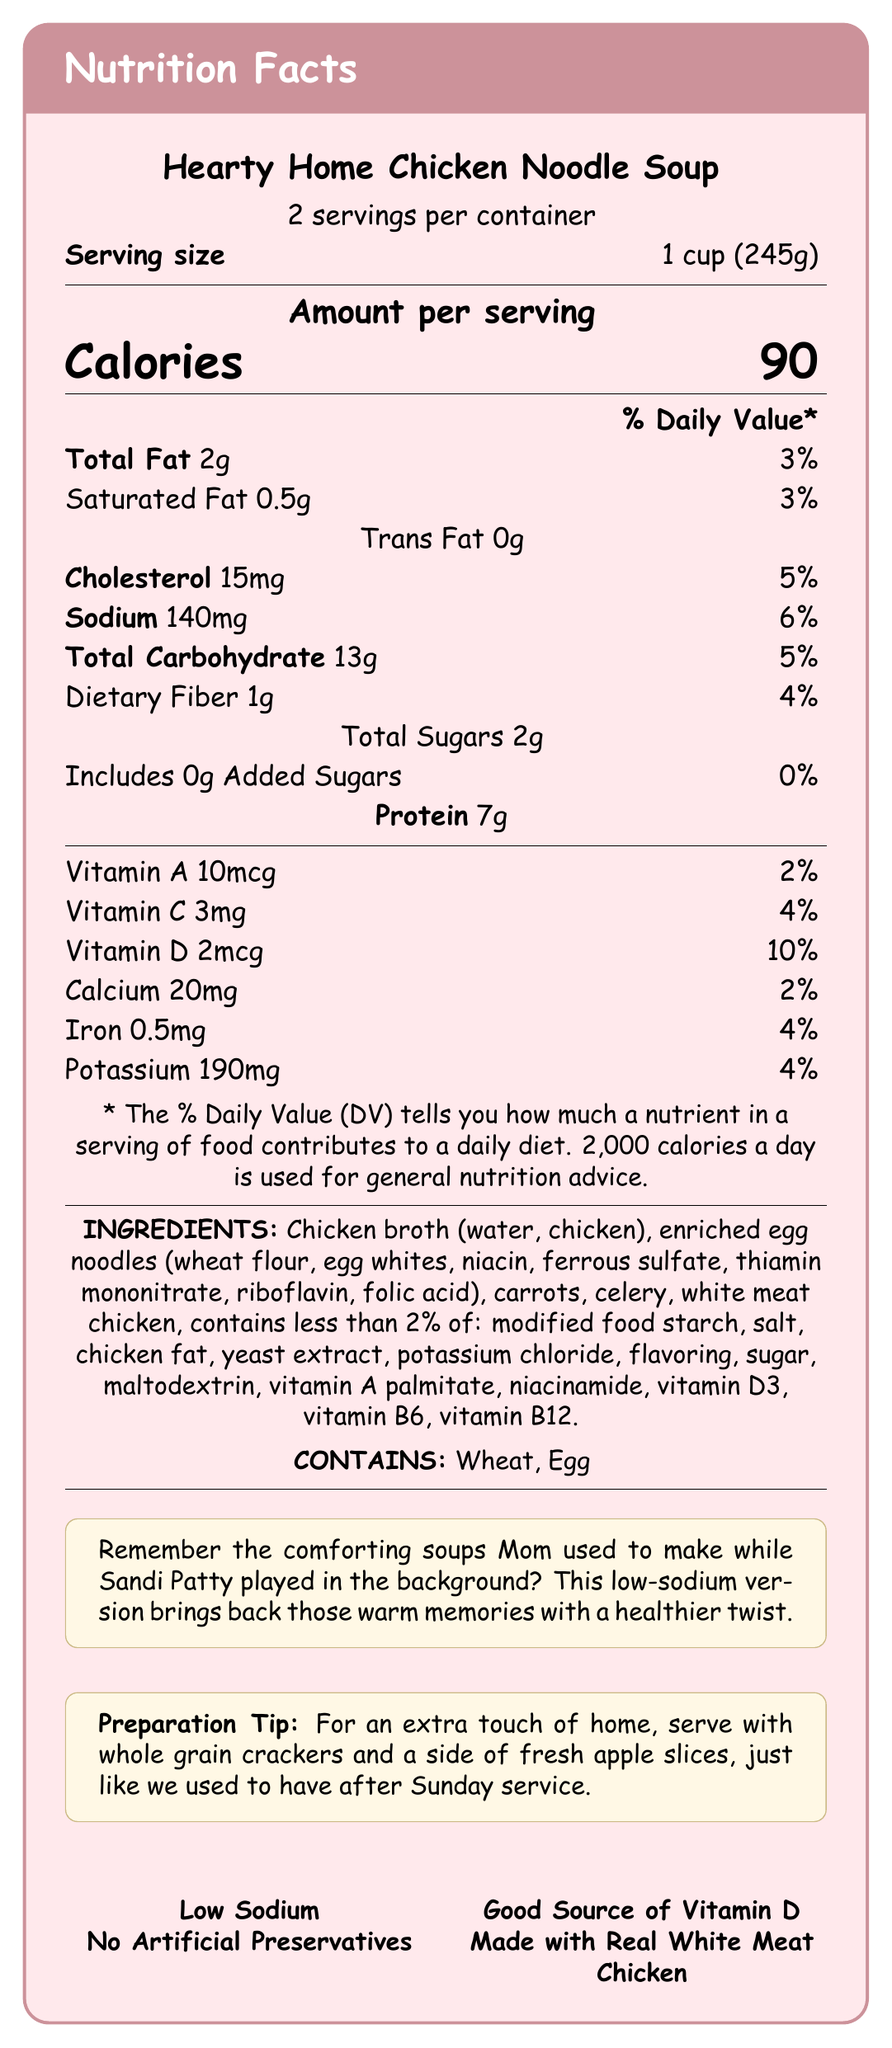what is the serving size of Hearty Home Chicken Noodle Soup? The document specifies that the serving size is 1 cup (245g).
Answer: 1 cup (245g) how many servings are in one container of Hearty Home Chicken Noodle Soup? The document mentions there are 2 servings per container.
Answer: 2 what is the sodium content per serving? The document lists the sodium amount per serving as 140mg.
Answer: 140mg how many grams of protein are in one serving? The document states that there is 7 grams of protein per serving.
Answer: 7g what percentage of daily value for Vitamin D does one serving of the soup provide? The document indicates that one serving provides 10% of the daily value for Vitamin D.
Answer: 10% which ingredients are identified as allergens in the Hearty Home Chicken Noodle Soup? A. Milk and Soy B. Wheat and Egg C. Peanut and Tree Nut D. Fish and Shellfish The allergens listed in the document are Wheat and Egg.
Answer: B which marketing claim is NOT mentioned on the document? A. Low Sodium B. No Artificial Preservatives C. Good Source of Vitamin D D. High Protein The document mentions Low Sodium, No Artificial Preservatives, and Good Source of Vitamin D, but not High Protein.
Answer: D does the soup contain any added sugars? The document states that the soup includes 0g added sugars, which means no added sugars are present.
Answer: No what is a nostalgic note mentioned in the document? The document includes this nostalgic note to evoke memories and relate to the product in an emotional way.
Answer: Remember the comforting soups Mom used to make while Sandi Patty played in the background? This low-sodium version brings back those warm memories with a healthier twist. summarize the main idea of the document. The document is a comprehensive Nutrition Facts Label for a chicken noodle soup product, highlighting its nutritional content, ingredients, allergens, and marketing points intended to evoke nostalgia and communicate its health benefits.
Answer: The document provides the Nutrition Facts Label for Hearty Home Chicken Noodle Soup. It details the nutritional information per serving, ingredients, allergens, marketing claims, and a nostalgic note. The soup is marketed as a low-sodium option with added vitamins and no artificial preservatives. is there any information on how to prepare the soup? The document includes a preparation tip: "For an extra touch of home, serve with whole grain crackers and a side of fresh apple slices, just like we used to have after Sunday service."
Answer: Yes how much iron does one serving contain? The document specifies that each serving contains 0.5mg of iron.
Answer: 0.5mg does the document specify the amount of Vitamin B6 in the soup? The document does not provide the amount of Vitamin B6. The information provided only goes up to Vitamin D3 inclusively.
Answer: No how many calories are in one container of the soup? Each serving is 90 calories, and since there are 2 servings per container, the total calories per container is 90 calories * 2 = 180 calories.
Answer: 180 calories 